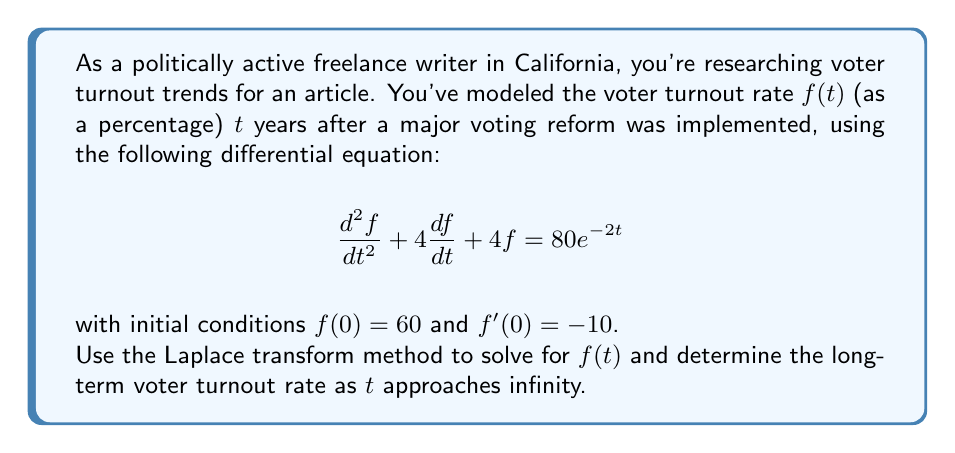Give your solution to this math problem. Let's solve this step-by-step using the Laplace transform method:

1) Take the Laplace transform of both sides of the equation:
   $$\mathcal{L}\{f''(t) + 4f'(t) + 4f(t)\} = \mathcal{L}\{80e^{-2t}\}$$

2) Using Laplace transform properties:
   $$[s^2F(s) - sf(0) - f'(0)] + 4[sF(s) - f(0)] + 4F(s) = \frac{80}{s+2}$$

3) Substitute the initial conditions $f(0) = 60$ and $f'(0) = -10$:
   $$[s^2F(s) - 60s + 10] + 4[sF(s) - 60] + 4F(s) = \frac{80}{s+2}$$

4) Simplify:
   $$s^2F(s) + 4sF(s) + 4F(s) - 60s - 230 = \frac{80}{s+2}$$
   $$(s^2 + 4s + 4)F(s) = \frac{80}{s+2} + 60s + 230$$

5) Factor the left side:
   $$(s+2)^2F(s) = \frac{80}{s+2} + 60s + 230$$

6) Solve for $F(s)$:
   $$F(s) = \frac{80}{(s+2)^3} + \frac{60s + 230}{(s+2)^2}$$

7) Decompose the right side:
   $$F(s) = \frac{80}{(s+2)^3} + \frac{60s + 230}{(s+2)^2} = \frac{80}{(s+2)^3} + \frac{60s + 120 + 110}{(s+2)^2} = \frac{80}{(s+2)^3} + \frac{60(s+2) + 110}{(s+2)^2}$$

8) Simplify:
   $$F(s) = \frac{80}{(s+2)^3} + \frac{60}{s+2} + \frac{110}{(s+2)^2}$$

9) Take the inverse Laplace transform:
   $$f(t) = 40t^2e^{-2t} + 60e^{-2t} + 110te^{-2t}$$

10) Simplify:
    $$f(t) = e^{-2t}(40t^2 + 110t + 60)$$

11) To find the long-term voter turnout rate, calculate the limit as $t$ approaches infinity:
    $$\lim_{t \to \infty} f(t) = \lim_{t \to \infty} e^{-2t}(40t^2 + 110t + 60) = 0$$
Answer: $f(t) = e^{-2t}(40t^2 + 110t + 60)$; long-term turnout rate: 0% 